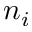<formula> <loc_0><loc_0><loc_500><loc_500>n _ { i }</formula> 